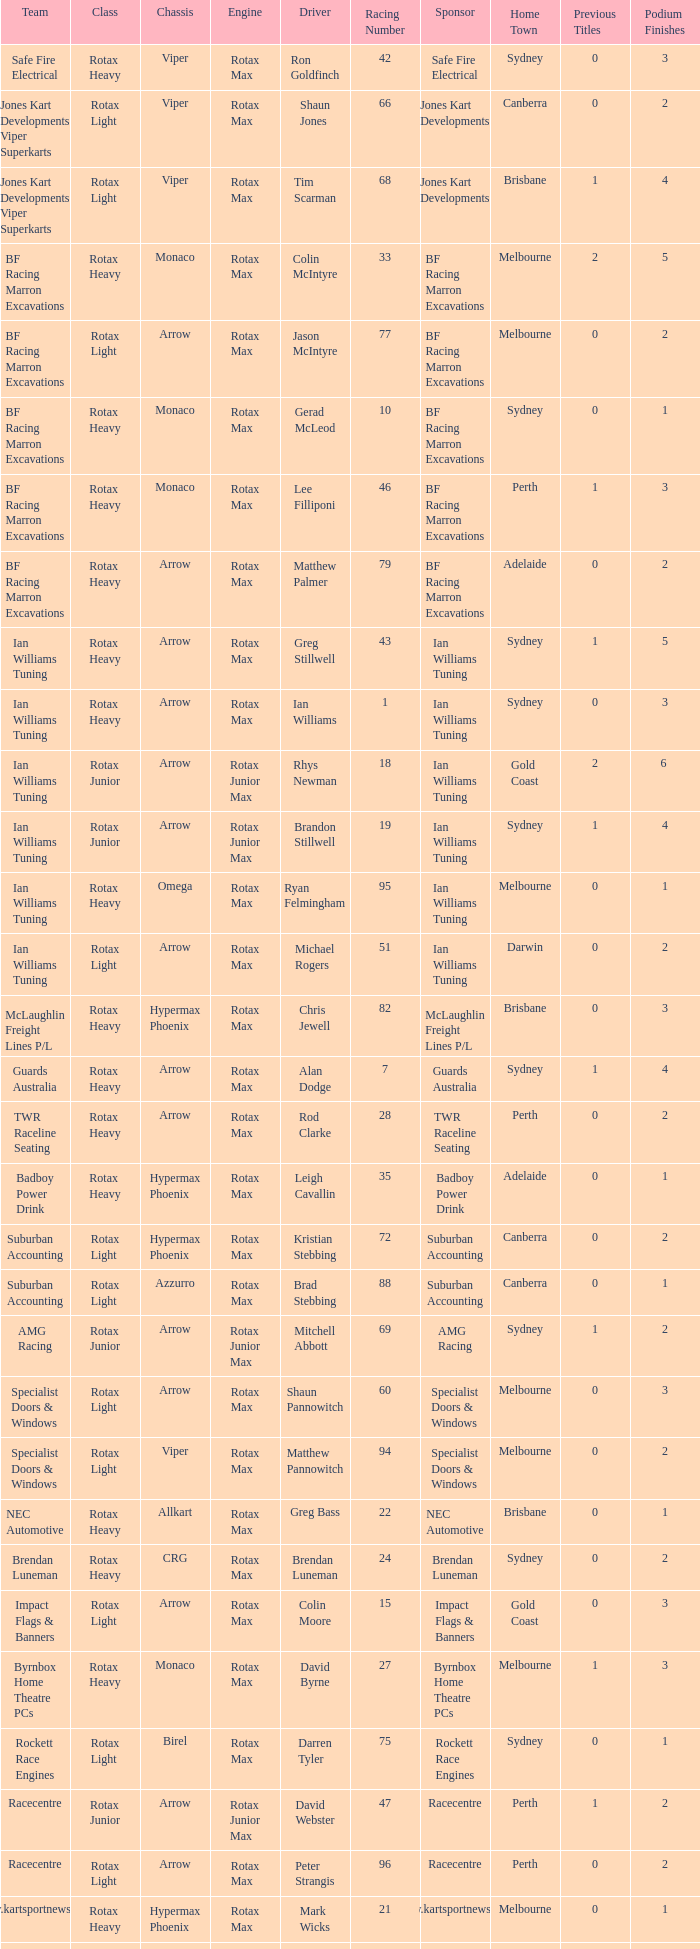What type of engine does the BF Racing Marron Excavations have that also has Monaco as chassis and Lee Filliponi as the driver? Rotax Max. 